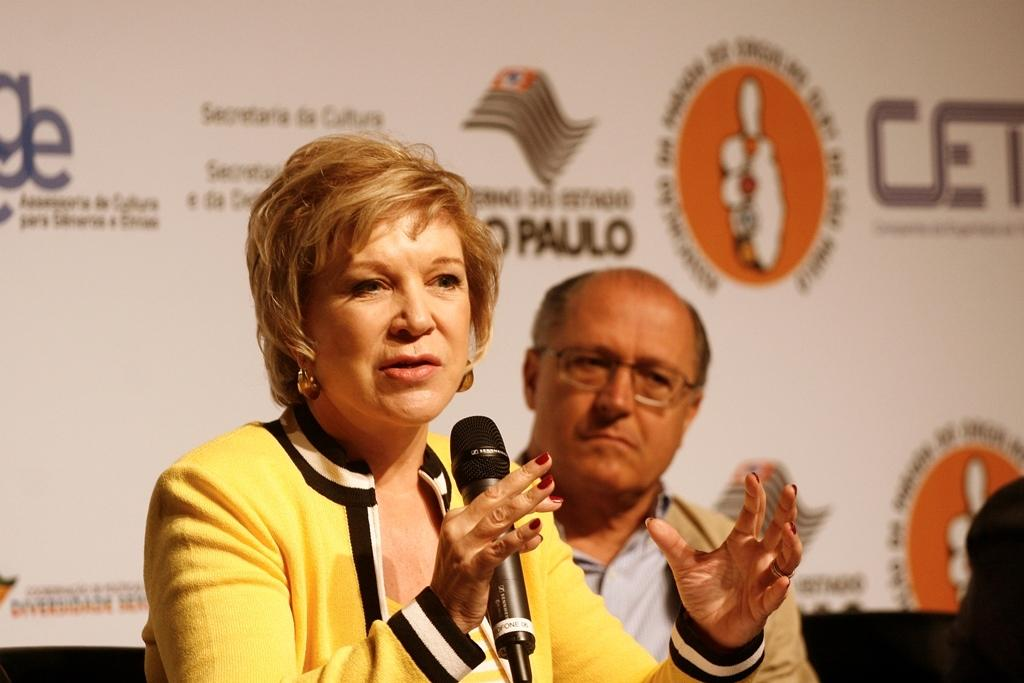Who is the main subject in the image? There is a woman in the image. What is the woman doing in the image? The woman is holding a microphone and speaking. Who else is present in the image? There is a man in the image. What is the man doing in the image? The man is watching. What object is visible in the image? There is a screen in the image. What type of pleasure can be seen on the sink in the image? There is no sink or pleasure present in the image. 